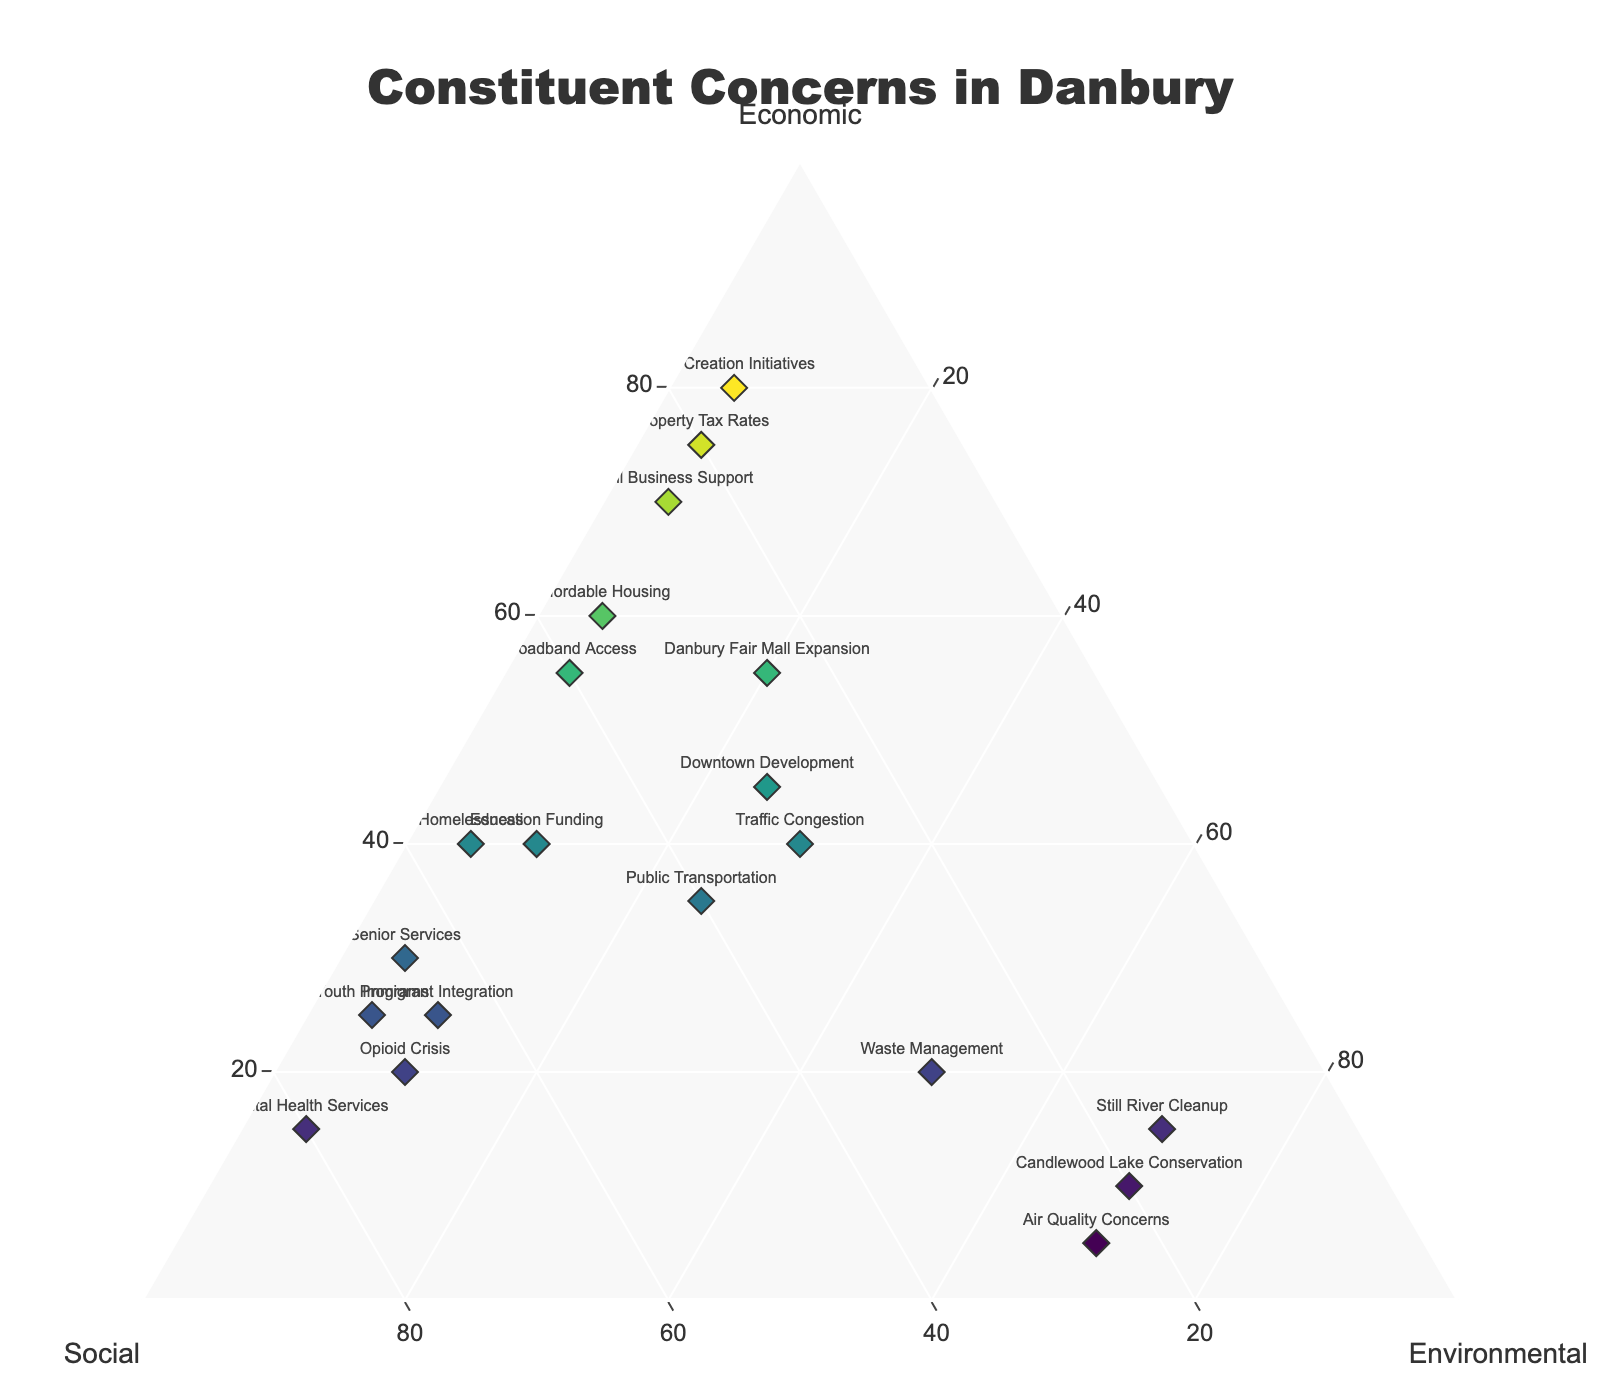What is the title of the figure? The title of the figure is usually located at the top center. In this case, it says 'Constituent Concerns in Danbury'.
Answer: 'Constituent Concerns in Danbury' Which constituent concern has the highest percentage of economic issues? By looking at the axis labeled 'Economic' and finding the highest value, 'Job Creation Initiatives' stands out with 80%.
Answer: 'Job Creation Initiatives' How many constituent concerns have an environmental percentage higher than 60%? By checking the axis labeled 'Environmental', three data points are above 60%: 'Still River Cleanup', 'Candlewood Lake Conservation', and 'Air Quality Concerns'.
Answer: 3 What constituent has an equal split between economic, social, and environmental concerns? An equal split means around 33.3% for each category. 'Traffic Congestion' is closest with 40% economic, 30% social, and 30% environmental.
Answer: 'Traffic Congestion' Are there more concerns with social issues as the dominant category or economic issues as the dominant category? Count the data points with the highest percentage in 'Social' versus 'Economic'. There are 7 data points with social as the highest and 6 with economic as the highest.
Answer: Social issues Which constituent has the lowest focus on environmental concerns? The lowest value in the 'Environmental' category is 5%. 'Affordable Housing', 'Property Tax Rates', 'Job Creation Initiatives', 'Small Business Support', 'Mental Health Services', 'Youth Programs', and 'Broadband Access' all have 5%.
Answer: 'Affordable Housing', 'Property Tax Rates', 'Job Creation Initiatives', 'Small Business Support', 'Mental Health Services', 'Youth Programs', 'Broadband Access' What is the average economic concern percentage for the given constituents? Add up all the economic percentages and divide by the number of data points. The sum is 655, and there are 19 data points: 655 / 19 ≈ 34.47.
Answer: 34.47% Which constituent resources combine to emphasize on social and environmental issues more than economic? Check the points where the sum of social and environmental percentages is greater than economic. 'Education Funding', 'Opioid Crisis', 'Senior Services', 'Candlewood Lake Conservation', 'Air Quality Concerns', 'Mental Health Services', 'Youth Programs', 'Waste Management', and 'Immigrant Integration' all fit.
Answer: ‘Education Funding’, 'Opioid Crisis', 'Senior Services', 'Candlewood Lake Conservation', 'Air Quality Concerns', 'Mental Health Services', 'Youth Programs', 'Waste Management', 'Immigrant Integration' What constituent has the closest balance of concerns across all three categories? A balanced concern would have similar percentages for each category. 'Public Transportation' has 35% economic, 40% social, and 25% environmental concerns, making it the closest to balance.
Answer: 'Public Transportation' 